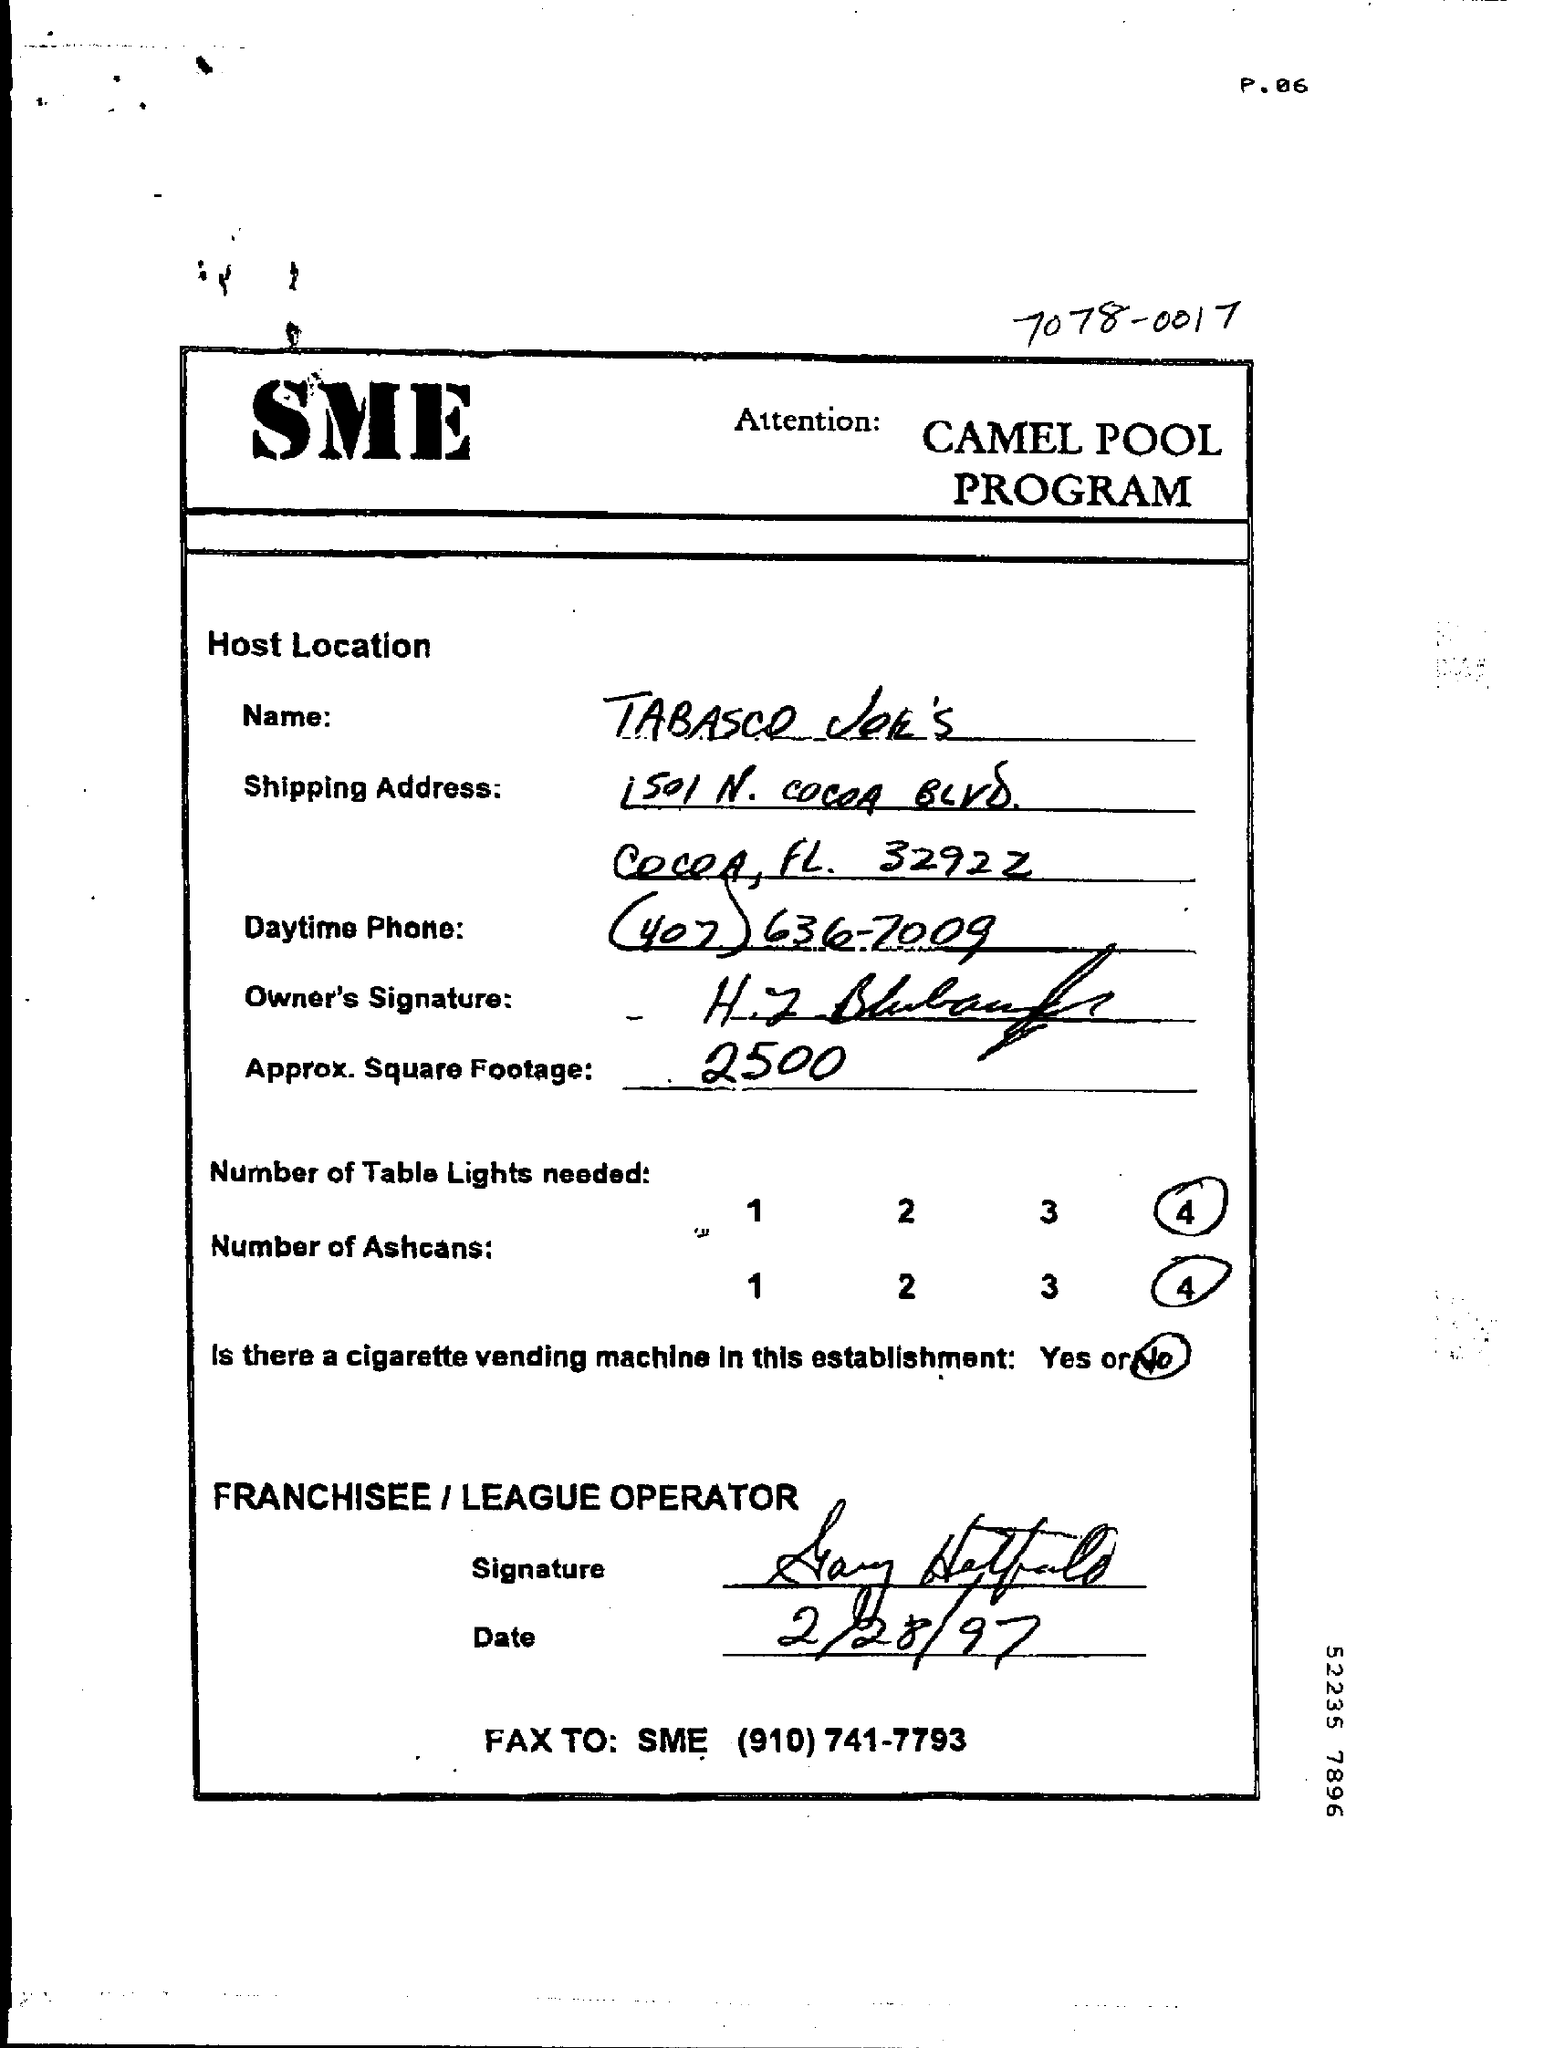Mention a couple of crucial points in this snapshot. The approximate square footage is 2500 square feet. 